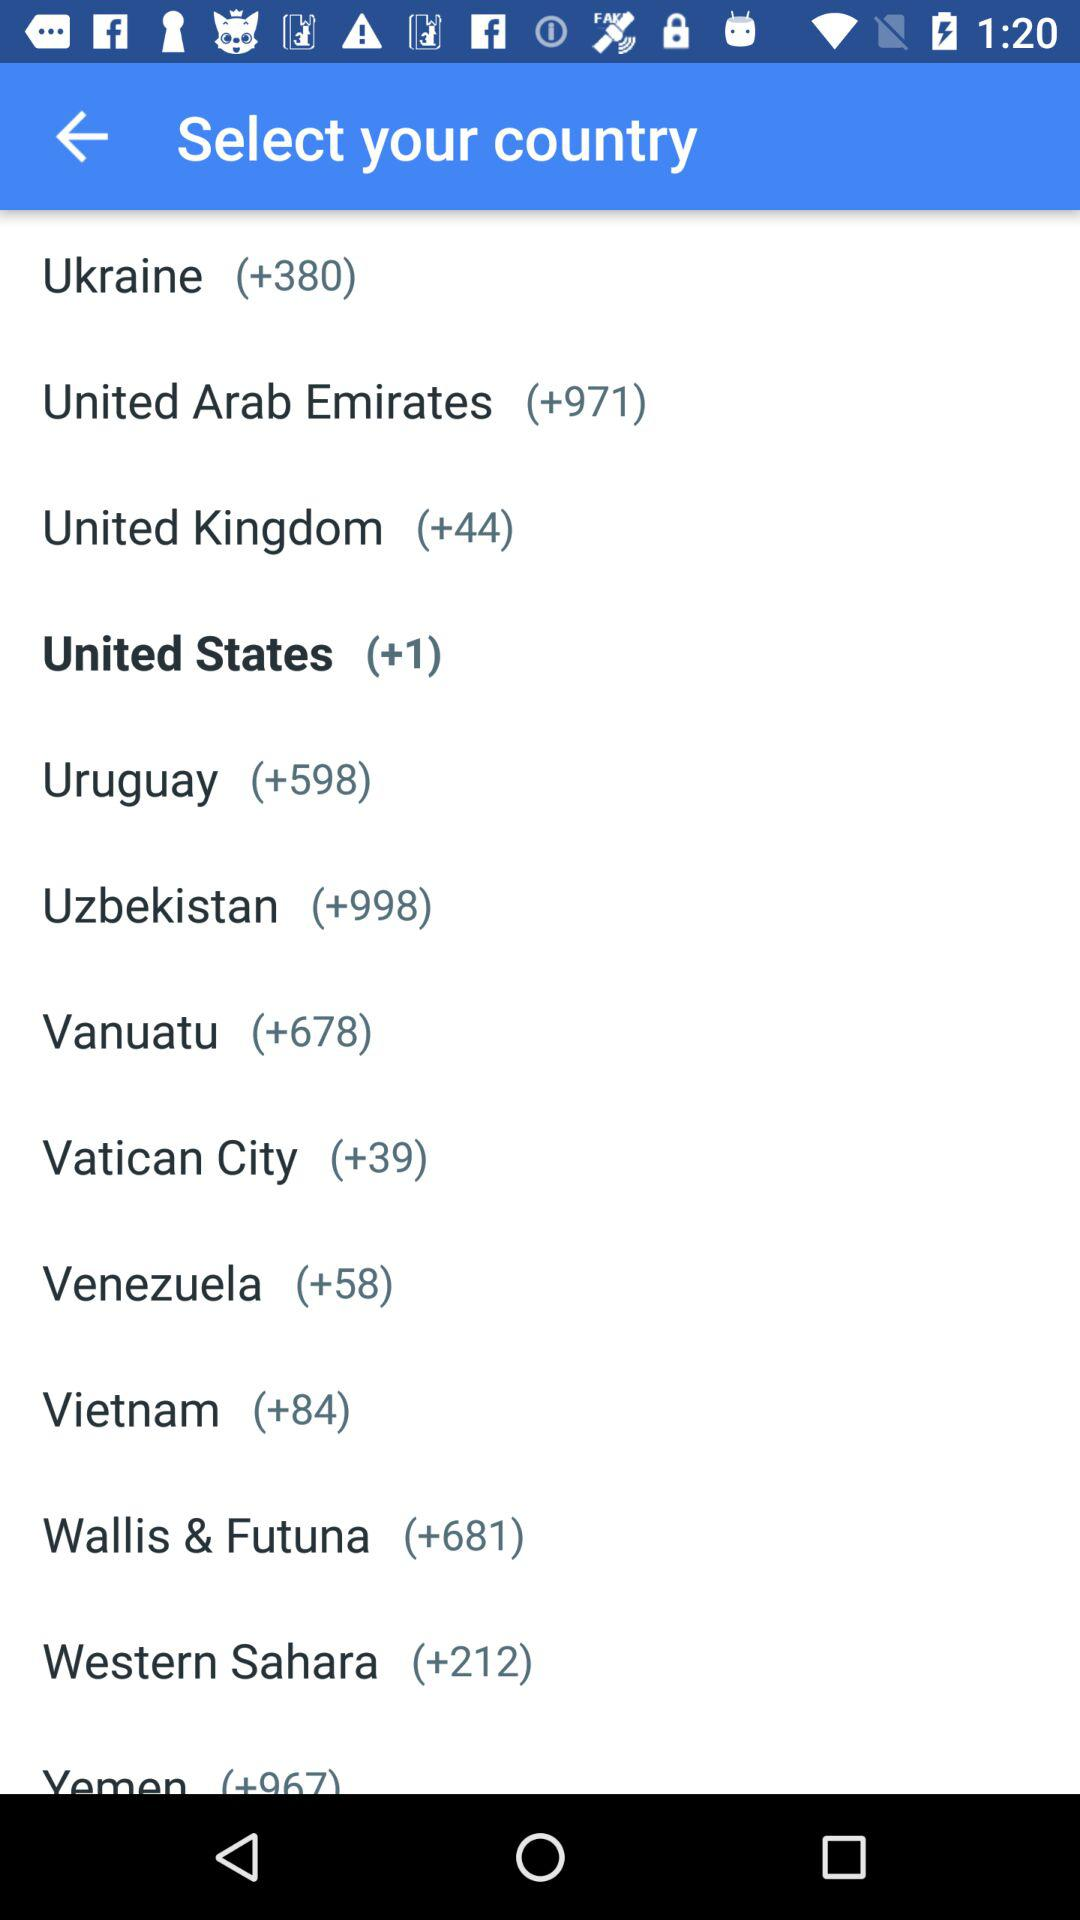What is the code of the highlighted country? The code is +1. 